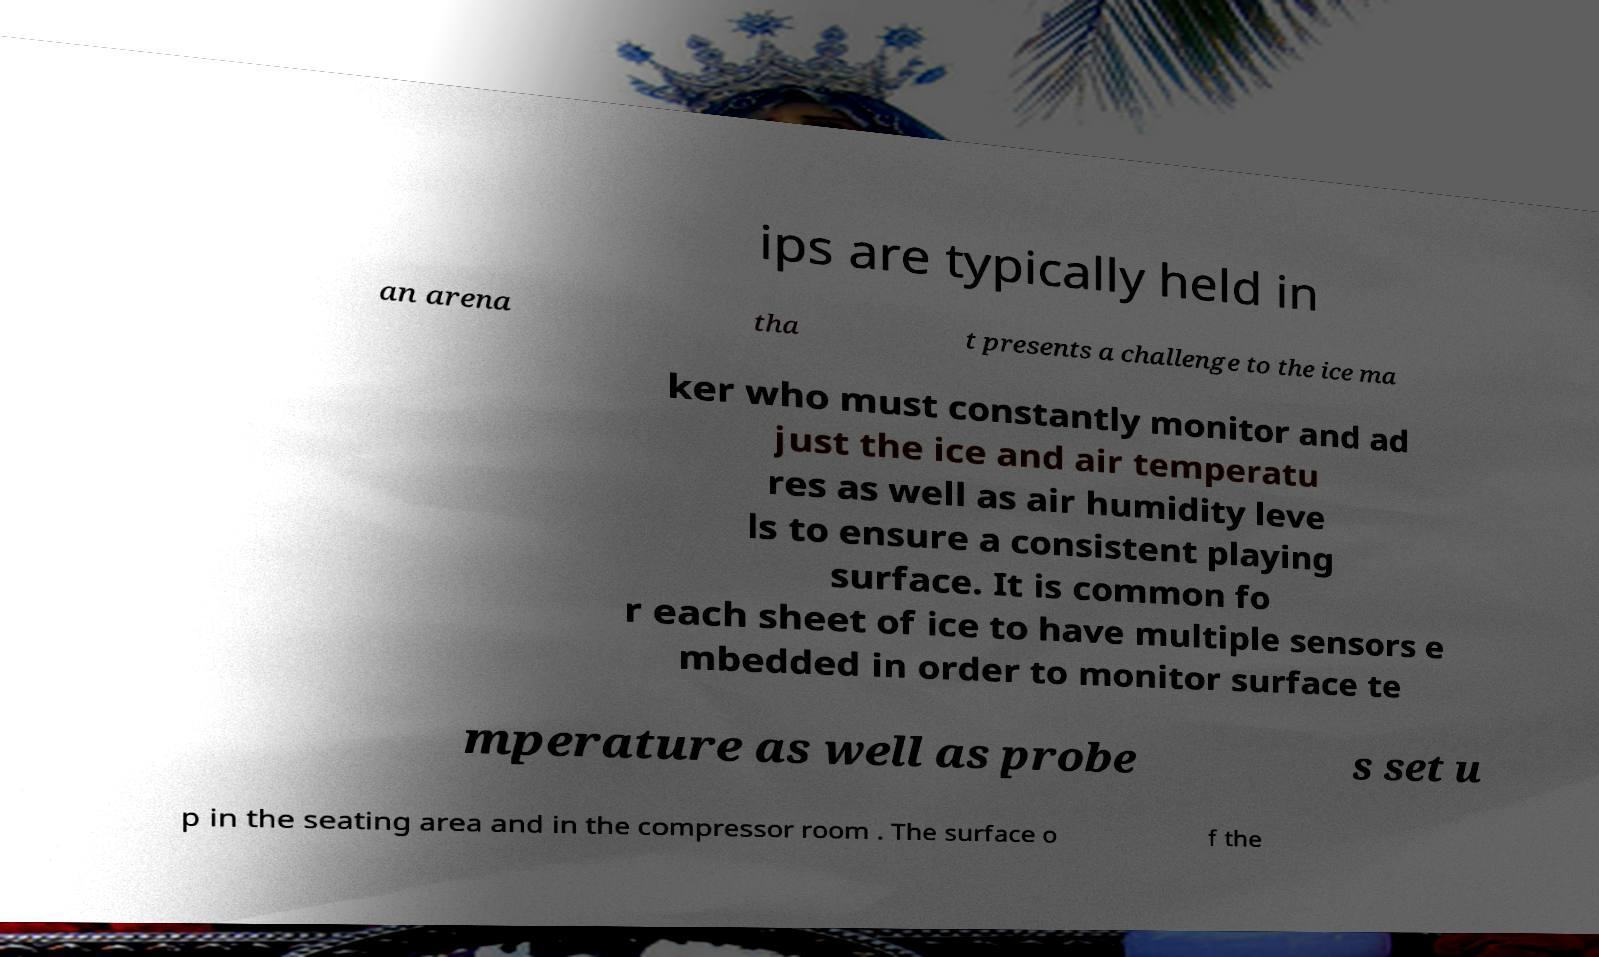I need the written content from this picture converted into text. Can you do that? ips are typically held in an arena tha t presents a challenge to the ice ma ker who must constantly monitor and ad just the ice and air temperatu res as well as air humidity leve ls to ensure a consistent playing surface. It is common fo r each sheet of ice to have multiple sensors e mbedded in order to monitor surface te mperature as well as probe s set u p in the seating area and in the compressor room . The surface o f the 